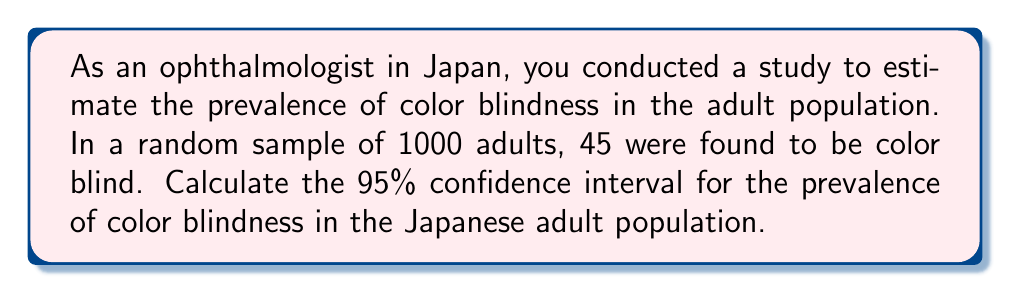Can you answer this question? To calculate the 95% confidence interval for the prevalence of color blindness, we'll use the formula for a binomial proportion confidence interval:

$$ p \pm z \sqrt{\frac{p(1-p)}{n}} $$

Where:
- $p$ is the sample proportion
- $z$ is the z-score for the desired confidence level (1.96 for 95% CI)
- $n$ is the sample size

Step 1: Calculate the sample proportion (p)
$$ p = \frac{45}{1000} = 0.045 $$

Step 2: Calculate the standard error (SE)
$$ SE = \sqrt{\frac{p(1-p)}{n}} = \sqrt{\frac{0.045(1-0.045)}{1000}} = 0.00656 $$

Step 3: Calculate the margin of error (ME)
$$ ME = z \times SE = 1.96 \times 0.00656 = 0.01286 $$

Step 4: Calculate the lower and upper bounds of the confidence interval
Lower bound: $0.045 - 0.01286 = 0.03214$
Upper bound: $0.045 + 0.01286 = 0.05786$

Therefore, the 95% confidence interval for the prevalence of color blindness in the Japanese adult population is (0.03214, 0.05786) or (3.21%, 5.79%).
Answer: (3.21%, 5.79%) 